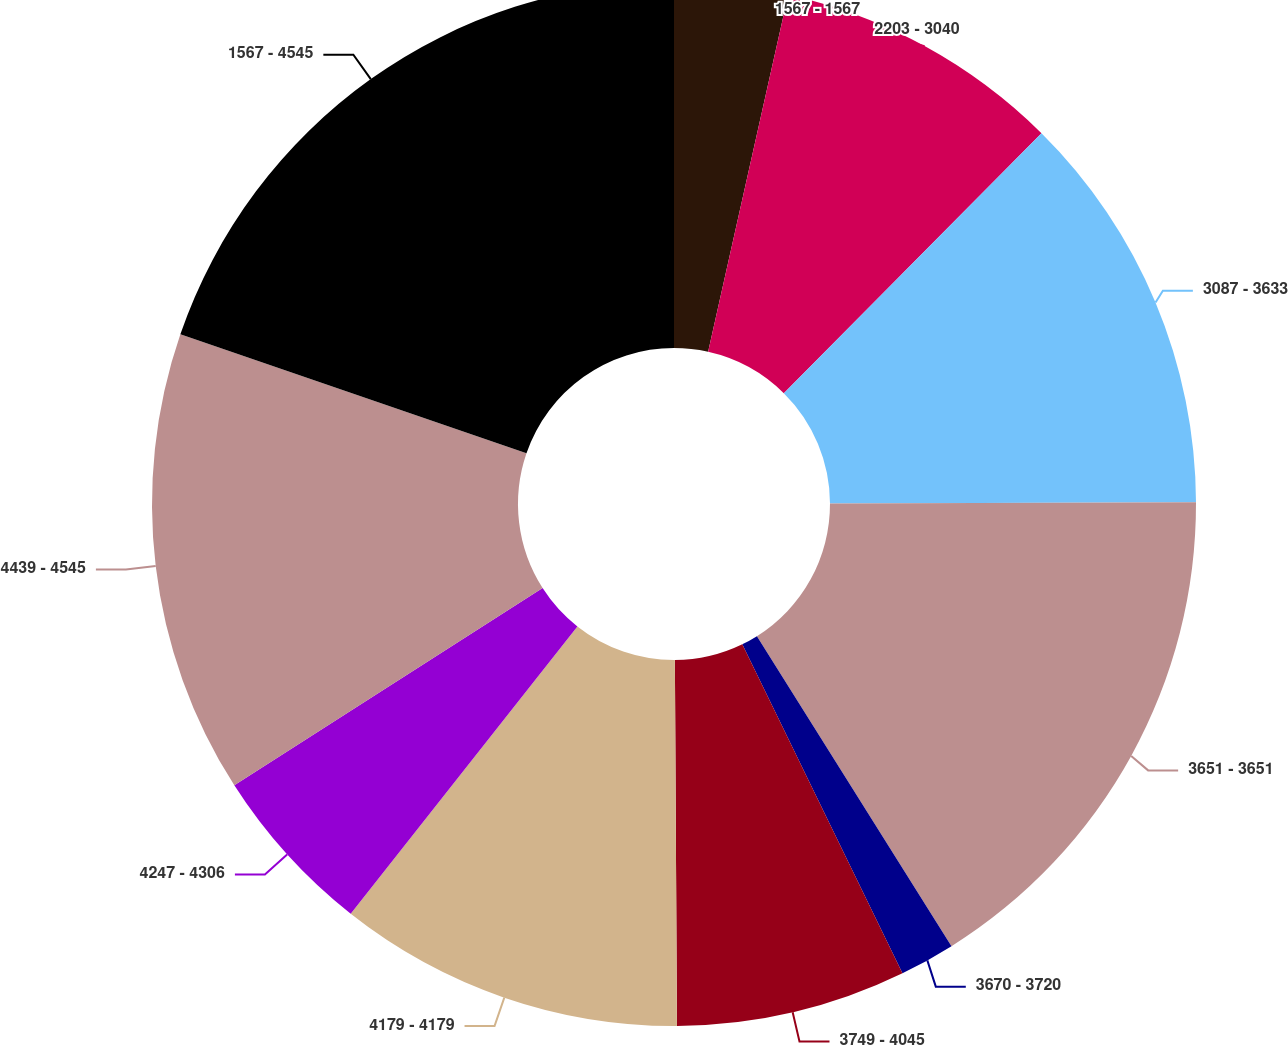Convert chart. <chart><loc_0><loc_0><loc_500><loc_500><pie_chart><fcel>1567 - 1567<fcel>2203 - 3040<fcel>3087 - 3633<fcel>3651 - 3651<fcel>3670 - 3720<fcel>3749 - 4045<fcel>4179 - 4179<fcel>4247 - 4306<fcel>4439 - 4545<fcel>1567 - 4545<nl><fcel>3.51%<fcel>8.92%<fcel>12.52%<fcel>16.13%<fcel>1.71%<fcel>7.12%<fcel>10.72%<fcel>5.31%<fcel>14.33%<fcel>19.73%<nl></chart> 